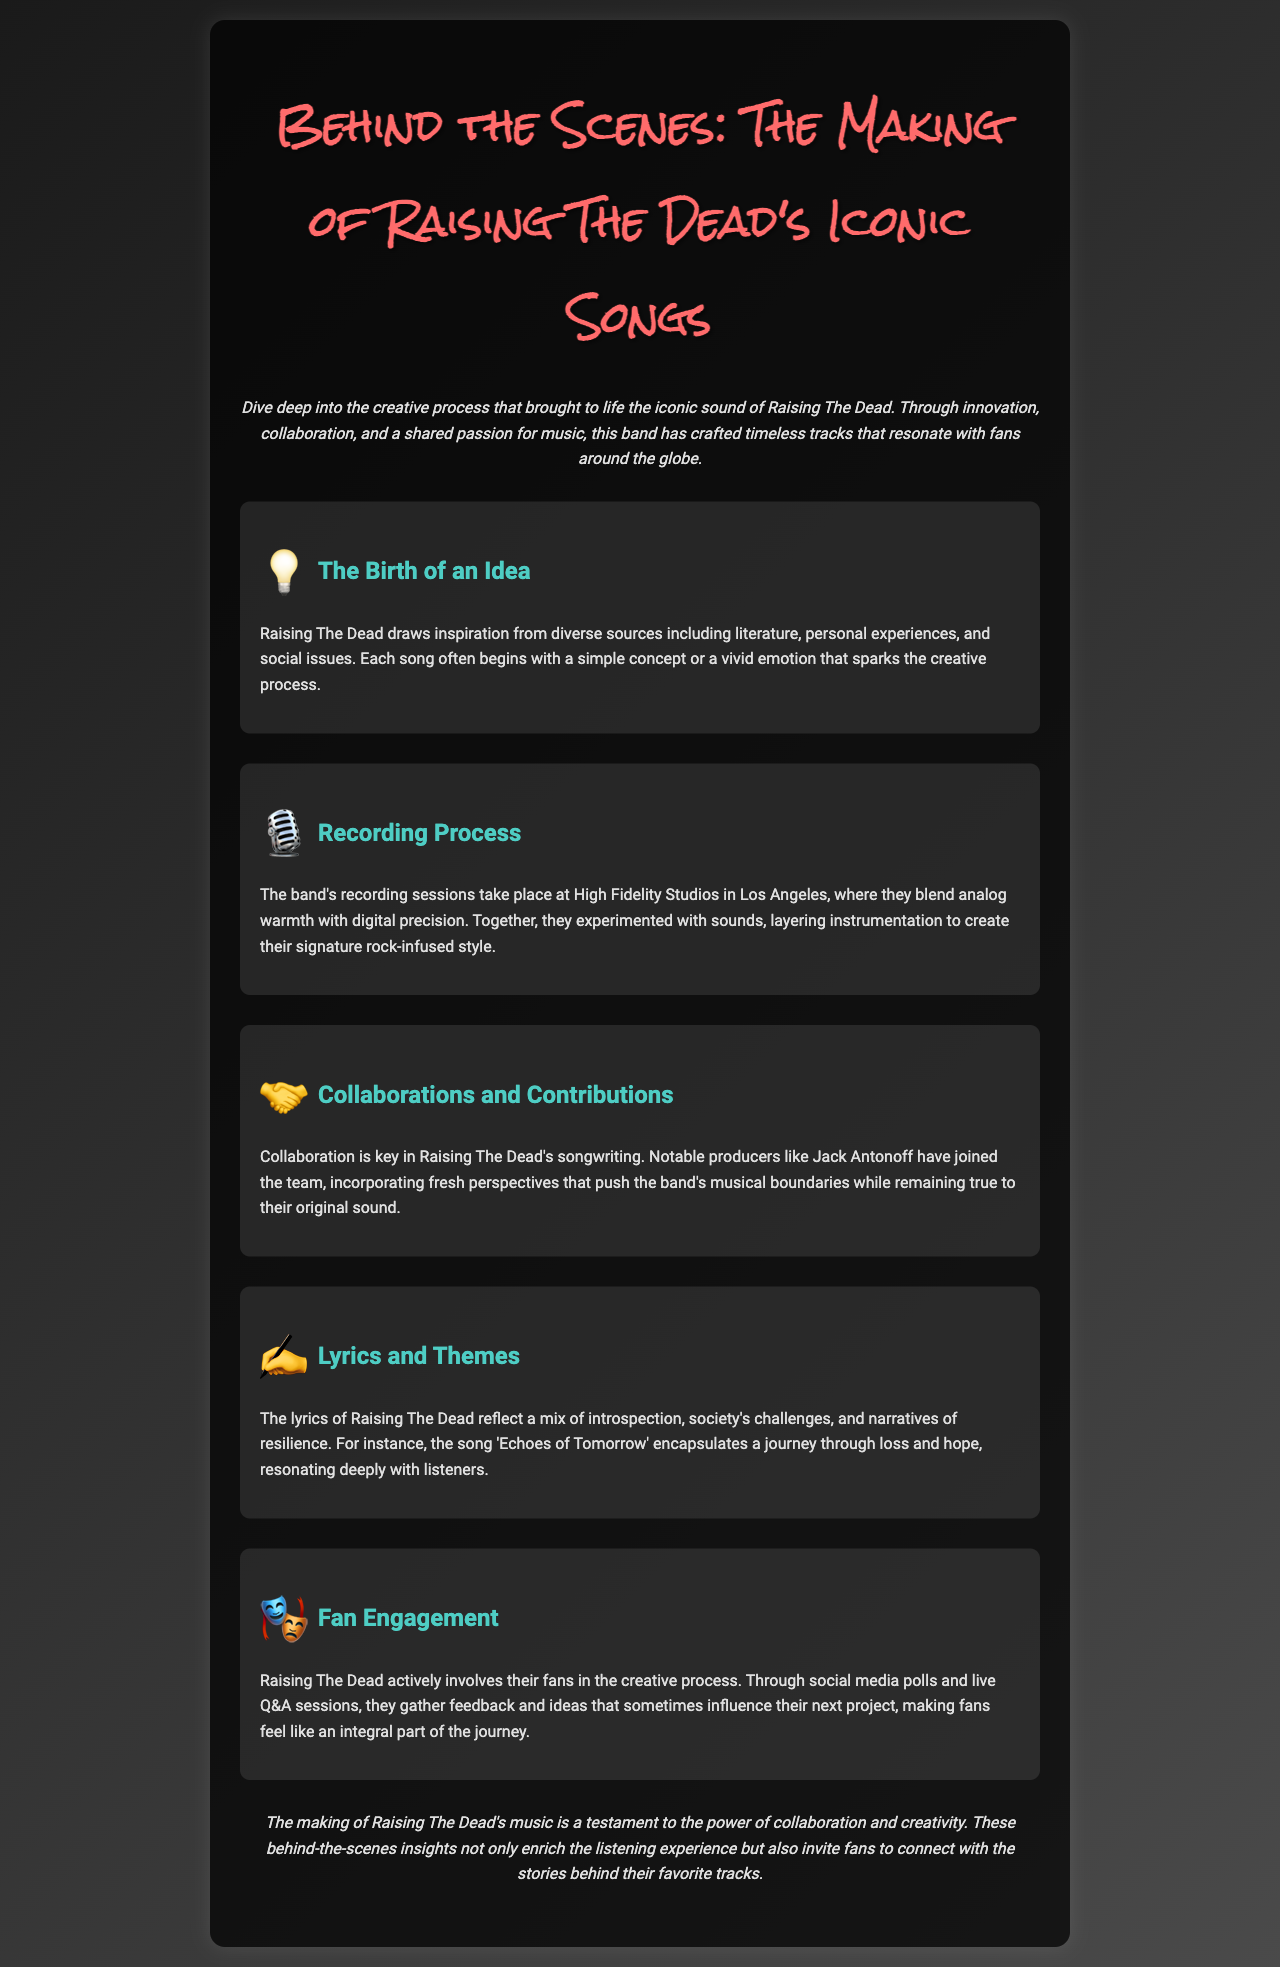What is the title of the brochure? The title of the brochure is at the top of the document and introduces the main theme, which is an exploration of the band's music-making process.
Answer: Behind the Scenes: The Making of Raising The Dead's Iconic Songs Where do Raising The Dead record their music? The document specifies the recording location, emphasizing the studio's quality and the band's approach to sound.
Answer: High Fidelity Studios in Los Angeles Who is a notable producer associated with the band? The document mentions a specific individual known for their work with Raising The Dead, highlighting collaboration in the music-making process.
Answer: Jack Antonoff What is the theme of the song 'Echoes of Tomorrow'? The document details a specific song's themes, illustrating the band's lyrical approach and emotional depth.
Answer: A journey through loss and hope How does Raising The Dead engage with fans? The document describes the methods the band uses to connect with their audience and incorporate their feedback into the creative process.
Answer: Through social media polls and live Q&A sessions What inspires the songs of Raising The Dead? The document discusses various influences behind the songwriting, offering insight into the band's creative sources.
Answer: Diverse sources including literature, personal experiences, and social issues What is the main idea conveyed in the conclusion? The conclusion summarizes the insights shared throughout the brochure, reflecting on the overarching theme of collaboration in music-making.
Answer: The power of collaboration and creativity What is the overall tone of the introduction? The introduction sets the mood for the brochure, establishing an inviting perspective on the band's music-making journey.
Answer: Creative and inviting 